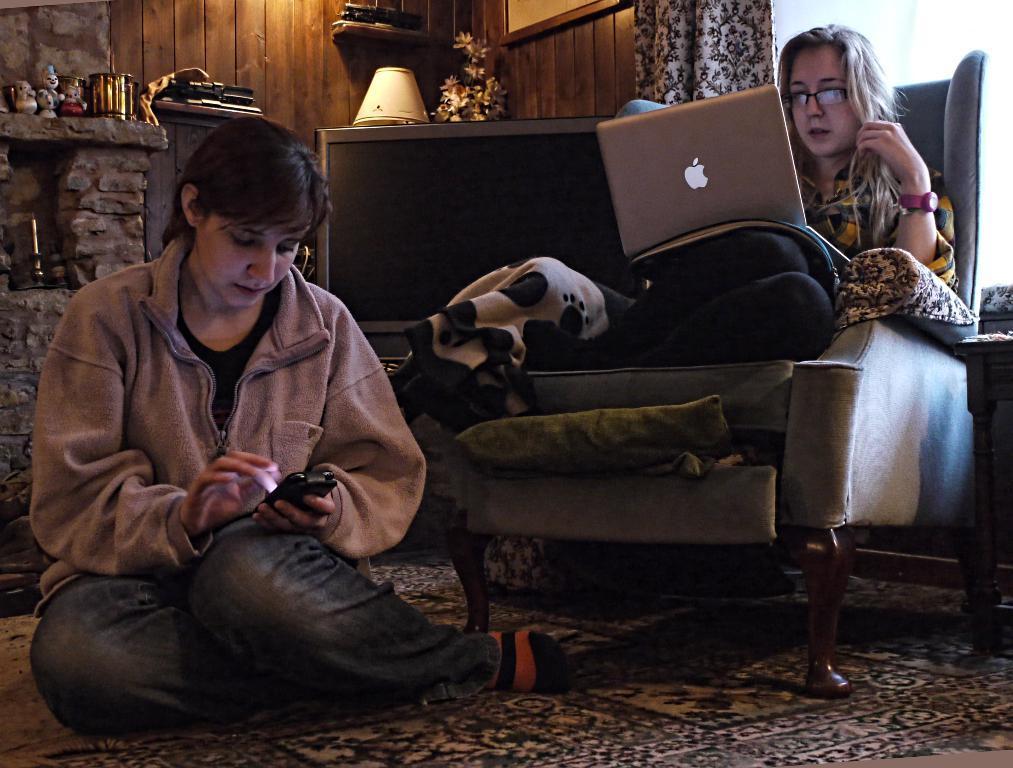Can you describe this image briefly? In this picture there are two people , one sitting on the floor and operating a mobile and the other one is sitting on a chair and operating a laptop. In the background we observe wooden wall, curtains, flower pots and a brick wall. 